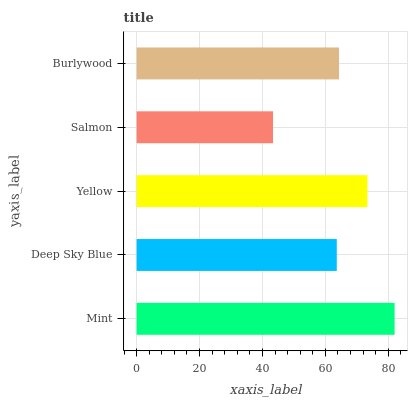Is Salmon the minimum?
Answer yes or no. Yes. Is Mint the maximum?
Answer yes or no. Yes. Is Deep Sky Blue the minimum?
Answer yes or no. No. Is Deep Sky Blue the maximum?
Answer yes or no. No. Is Mint greater than Deep Sky Blue?
Answer yes or no. Yes. Is Deep Sky Blue less than Mint?
Answer yes or no. Yes. Is Deep Sky Blue greater than Mint?
Answer yes or no. No. Is Mint less than Deep Sky Blue?
Answer yes or no. No. Is Burlywood the high median?
Answer yes or no. Yes. Is Burlywood the low median?
Answer yes or no. Yes. Is Deep Sky Blue the high median?
Answer yes or no. No. Is Yellow the low median?
Answer yes or no. No. 